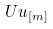Convert formula to latex. <formula><loc_0><loc_0><loc_500><loc_500>\ U u _ { \left [ m \right ] }</formula> 